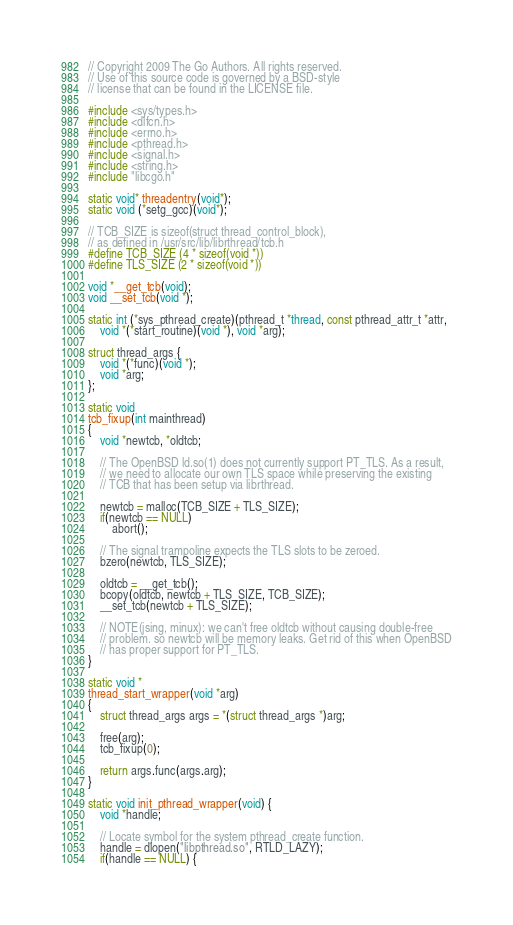<code> <loc_0><loc_0><loc_500><loc_500><_C_>// Copyright 2009 The Go Authors. All rights reserved.
// Use of this source code is governed by a BSD-style
// license that can be found in the LICENSE file.

#include <sys/types.h>
#include <dlfcn.h>
#include <errno.h>
#include <pthread.h>
#include <signal.h>
#include <string.h>
#include "libcgo.h"

static void* threadentry(void*);
static void (*setg_gcc)(void*);

// TCB_SIZE is sizeof(struct thread_control_block),
// as defined in /usr/src/lib/librthread/tcb.h
#define TCB_SIZE (4 * sizeof(void *))
#define TLS_SIZE (2 * sizeof(void *))

void *__get_tcb(void);
void __set_tcb(void *);

static int (*sys_pthread_create)(pthread_t *thread, const pthread_attr_t *attr,
	void *(*start_routine)(void *), void *arg);

struct thread_args {
	void *(*func)(void *);
	void *arg;
};

static void
tcb_fixup(int mainthread)
{
	void *newtcb, *oldtcb;

	// The OpenBSD ld.so(1) does not currently support PT_TLS. As a result,
	// we need to allocate our own TLS space while preserving the existing
	// TCB that has been setup via librthread.

	newtcb = malloc(TCB_SIZE + TLS_SIZE);
	if(newtcb == NULL)
		abort();

	// The signal trampoline expects the TLS slots to be zeroed.
	bzero(newtcb, TLS_SIZE);

	oldtcb = __get_tcb();
	bcopy(oldtcb, newtcb + TLS_SIZE, TCB_SIZE);
	__set_tcb(newtcb + TLS_SIZE);

	// NOTE(jsing, minux): we can't free oldtcb without causing double-free
	// problem. so newtcb will be memory leaks. Get rid of this when OpenBSD
	// has proper support for PT_TLS.
}

static void *
thread_start_wrapper(void *arg)
{
	struct thread_args args = *(struct thread_args *)arg;

	free(arg);
	tcb_fixup(0);

	return args.func(args.arg);
}

static void init_pthread_wrapper(void) {
	void *handle;

	// Locate symbol for the system pthread_create function.
	handle = dlopen("libpthread.so", RTLD_LAZY);
	if(handle == NULL) {</code> 